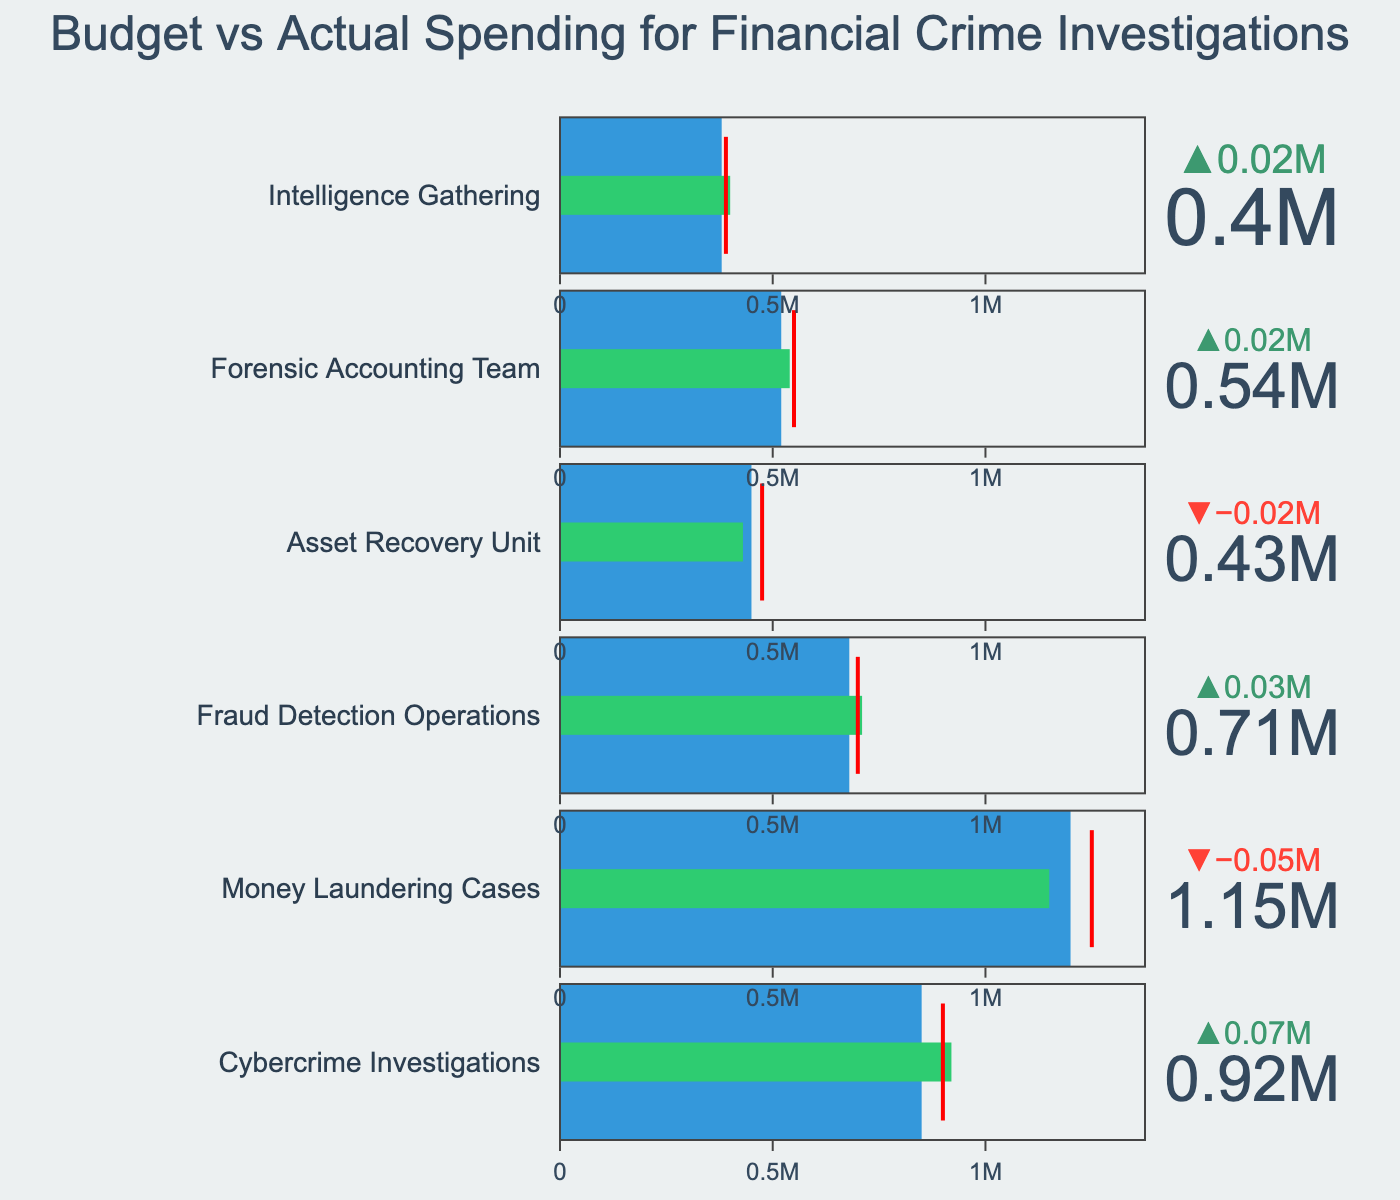What is the title of the figure? The title is typically at the top of the figure and is designed to give a summary of what the figure represents. In this case, the title is a summary of the subject matter of the Bullet Chart.
Answer: Budget vs Actual Spending for Financial Crime Investigations Which category has the highest actual spending? To find this, look at all the bars representing actual spending in each category and identify the bar that extends the furthest to the right. In the figure, 'Cybercrime Investigations' has the highest actual spending.
Answer: Cybercrime Investigations How much did the 'Money Laundering Cases' category spend compared to its budget? Find the 'Money Laundering Cases' row, and then subtract the budget value from the actual spending value. The actual spending is below the budget.
Answer: -50000 Which categories exceeded their budget? To answer this, identify all the bars where the actual spending (the green bar) extends beyond the blue budget zone. The bars must also exceed the target (indicated by a red line).
Answer: Cybercrime Investigations, Fraud Detection Operations, Forensic Accounting Team, Intelligence Gathering What is the difference between the actual spending and the target for the 'Asset Recovery Unit'? Look at the 'Asset Recovery Unit' and find the actual spending and the target values. Subtract the target value from the actual spending value.
Answer: -45000 In which category is the actual spending closest to the target? Identify the category where the actual spending (green bar) is nearest to the red line that represents the target.
Answer: Forensic Accounting Team Which category has the lowest budget? To find this, identify the smallest value among the budget numbers for all categories.
Answer: Intelligence Gathering Did any category not reach its target despite exceeding its budget? This requires checking categories that have actual spending higher than the budget but less than the target value marked by the red line.
Answer: None How much more did the 'Intelligence Gathering' category spend compared to its budget? To find this, locate the 'Intelligence Gathering' row and subtract the budget value from the actual spending value. The difference here is positive since the actual spending exceeds the budget.
Answer: 20000 